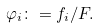Convert formula to latex. <formula><loc_0><loc_0><loc_500><loc_500>\varphi _ { i } \colon = f _ { i } / F .</formula> 